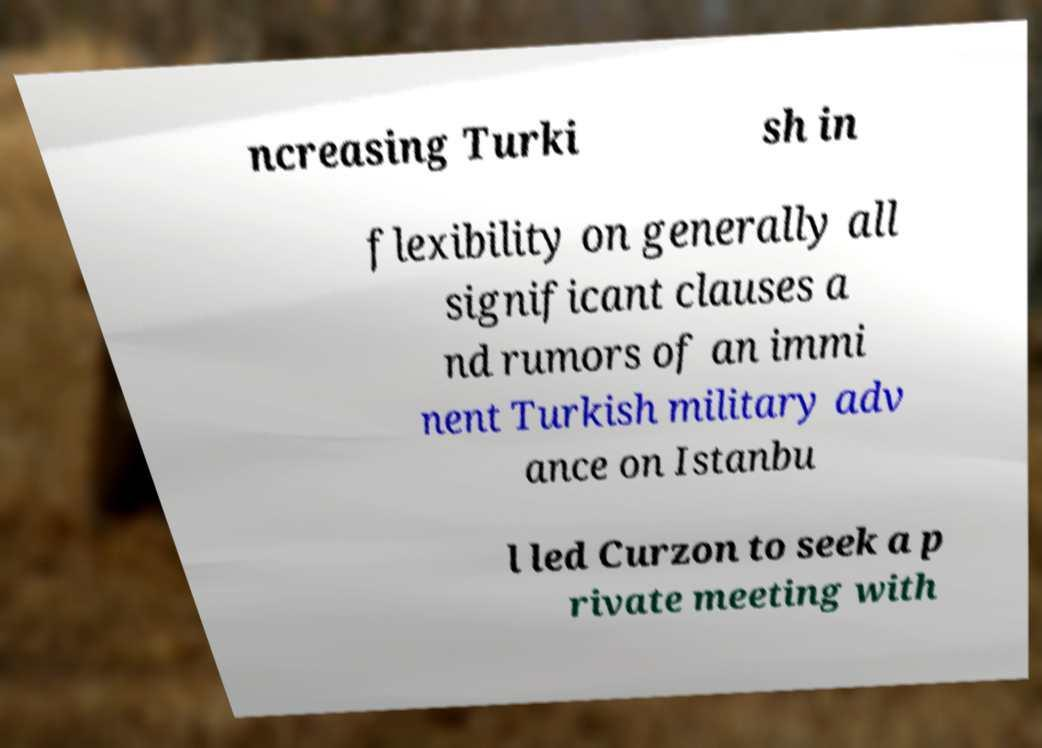Please identify and transcribe the text found in this image. ncreasing Turki sh in flexibility on generally all significant clauses a nd rumors of an immi nent Turkish military adv ance on Istanbu l led Curzon to seek a p rivate meeting with 